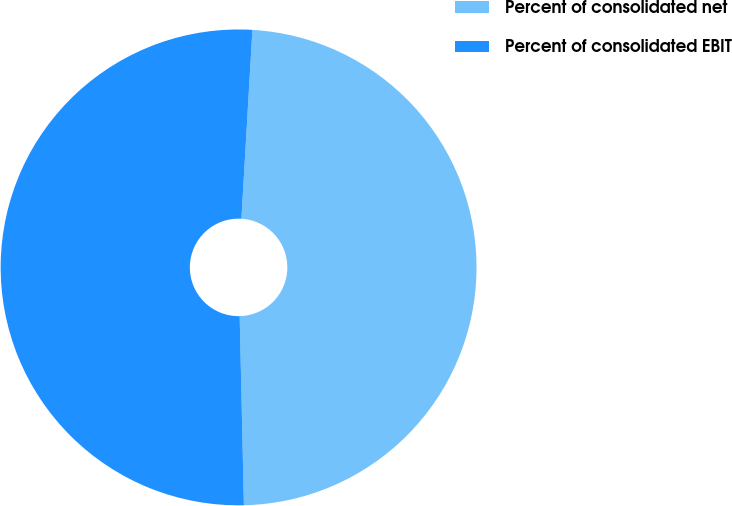Convert chart. <chart><loc_0><loc_0><loc_500><loc_500><pie_chart><fcel>Percent of consolidated net<fcel>Percent of consolidated EBIT<nl><fcel>48.72%<fcel>51.28%<nl></chart> 